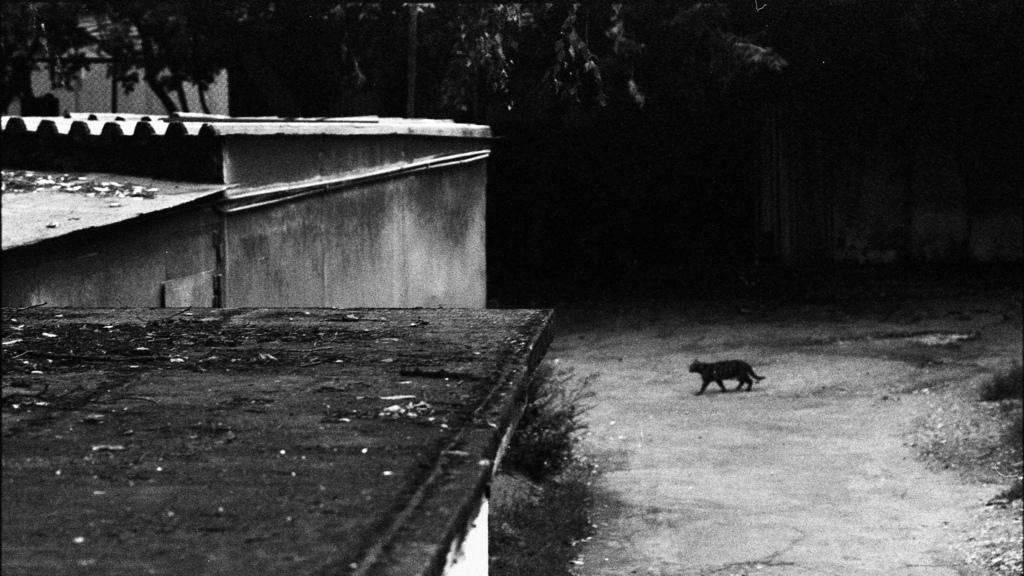What is the color scheme of the image? The image is black and white. What animal can be seen in the image? There is a cat in the image. What is the cat doing in the image? The cat is walking on the road. What structures are located on the left side of the image? There are buildings on the left side of the image. What type of vegetation can be seen in the background of the image? There are trees in the background of the image. What type of truck is parked near the cat in the image? There is no truck present in the image; it only features a cat walking on the road. How does the cat's memory affect its behavior in the image? The image does not provide any information about the cat's memory, so we cannot determine how it might affect its behavior. 